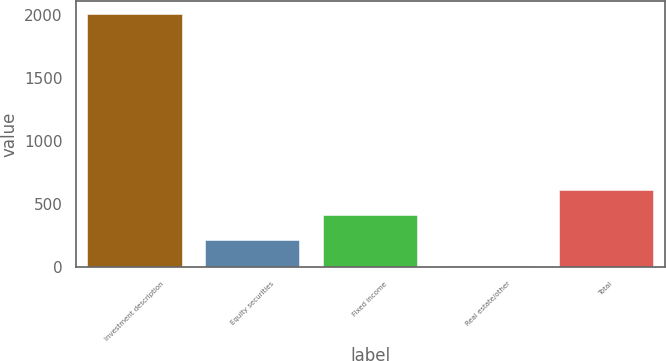Convert chart. <chart><loc_0><loc_0><loc_500><loc_500><bar_chart><fcel>Investment description<fcel>Equity securities<fcel>Fixed income<fcel>Real estate/other<fcel>Total<nl><fcel>2013<fcel>214.8<fcel>414.6<fcel>15<fcel>614.4<nl></chart> 